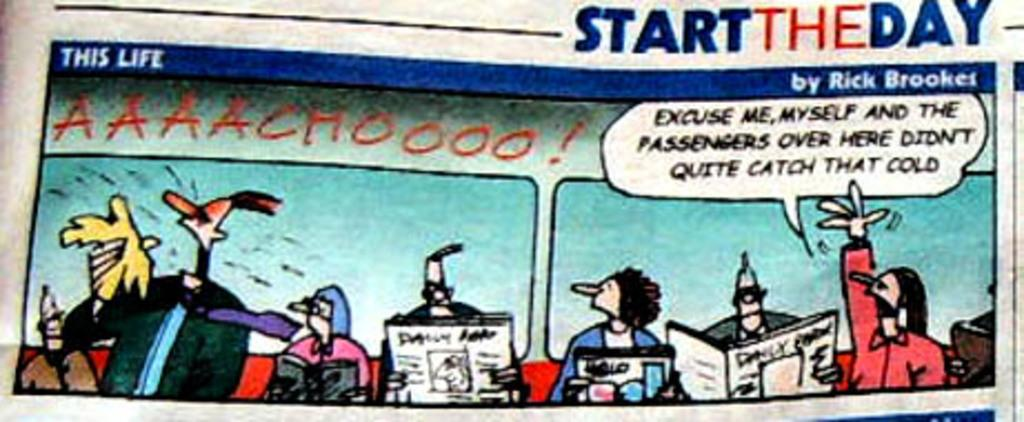What is the medium of the image? The image is on a paper. What type of images can be seen on the paper? There are cartoon images on the paper. What else is present on the paper besides the images? There are letters on the paper. Can you tell me the name of the girl who owns the plate in the image? There is no girl or plate present in the image; it only features cartoon images and letters on a paper. 